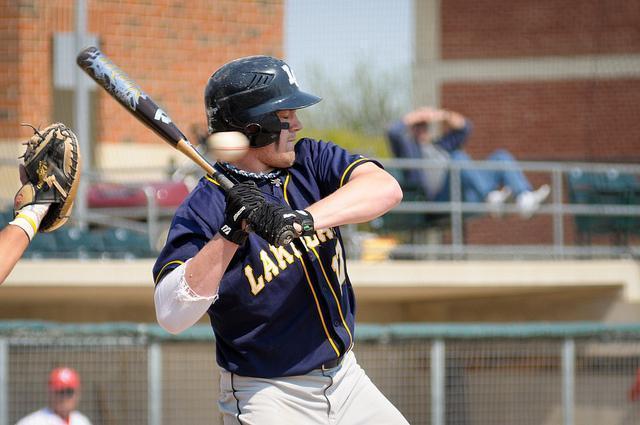How many baseball gloves are there?
Give a very brief answer. 2. How many people can be seen?
Give a very brief answer. 3. 